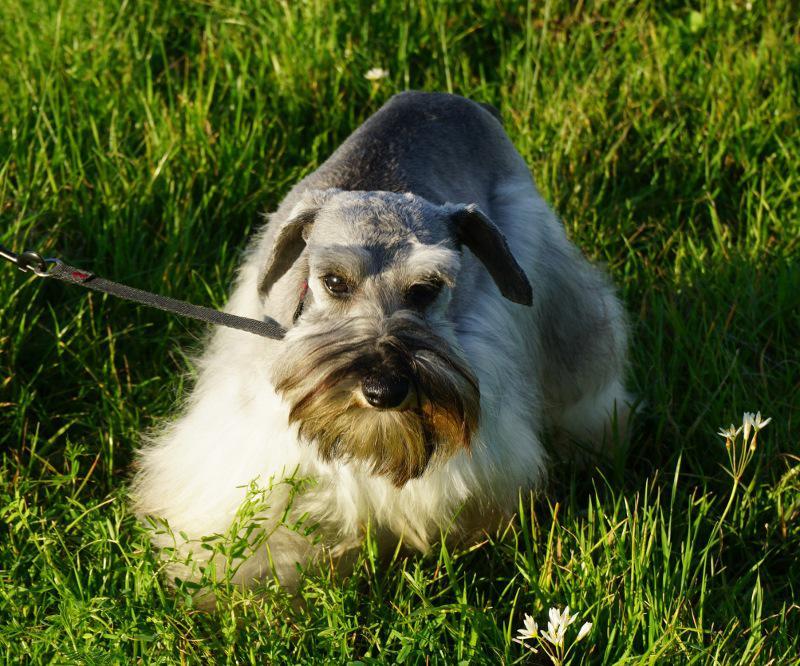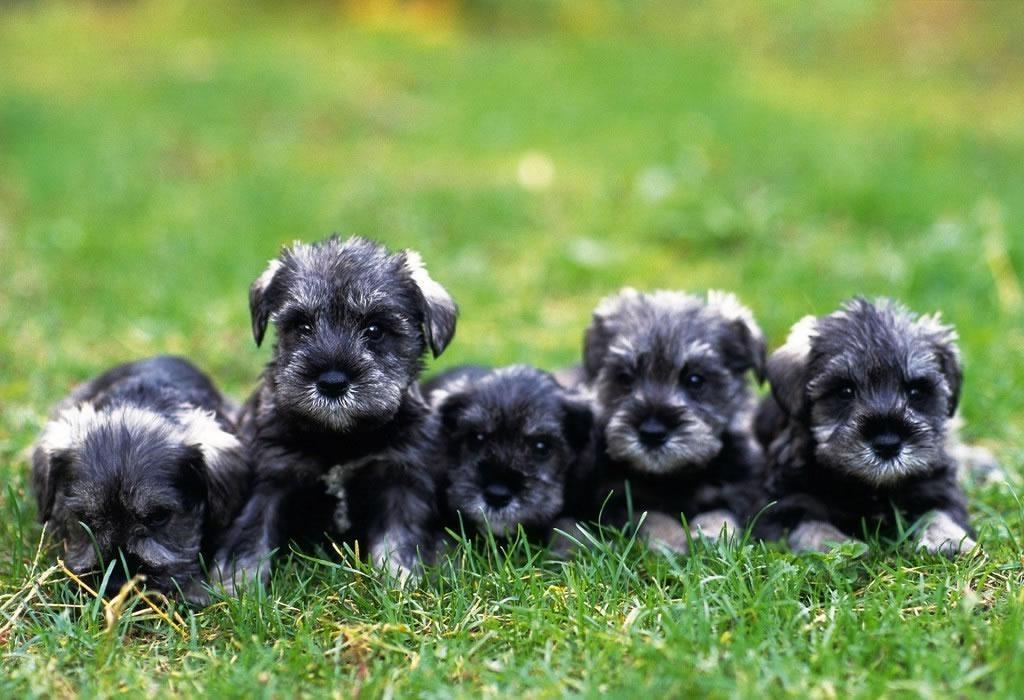The first image is the image on the left, the second image is the image on the right. Given the left and right images, does the statement "A long haired light colored dog is standing outside in the grass on a leash." hold true? Answer yes or no. Yes. The first image is the image on the left, the second image is the image on the right. For the images shown, is this caption "a dog is standing in the grass with a taught leash" true? Answer yes or no. Yes. 